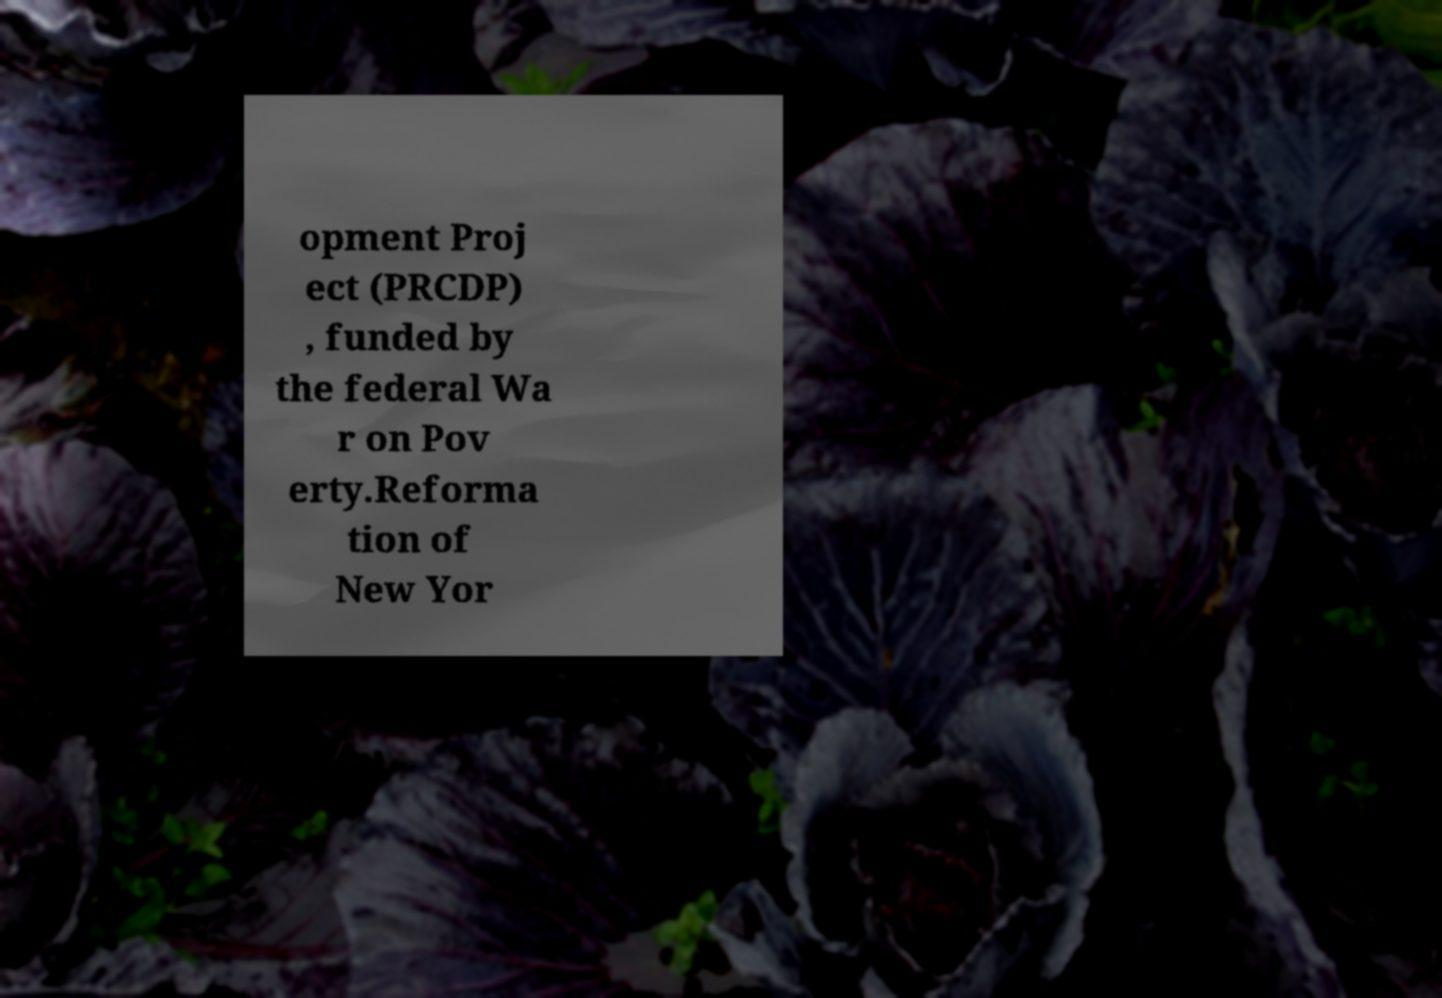For documentation purposes, I need the text within this image transcribed. Could you provide that? opment Proj ect (PRCDP) , funded by the federal Wa r on Pov erty.Reforma tion of New Yor 